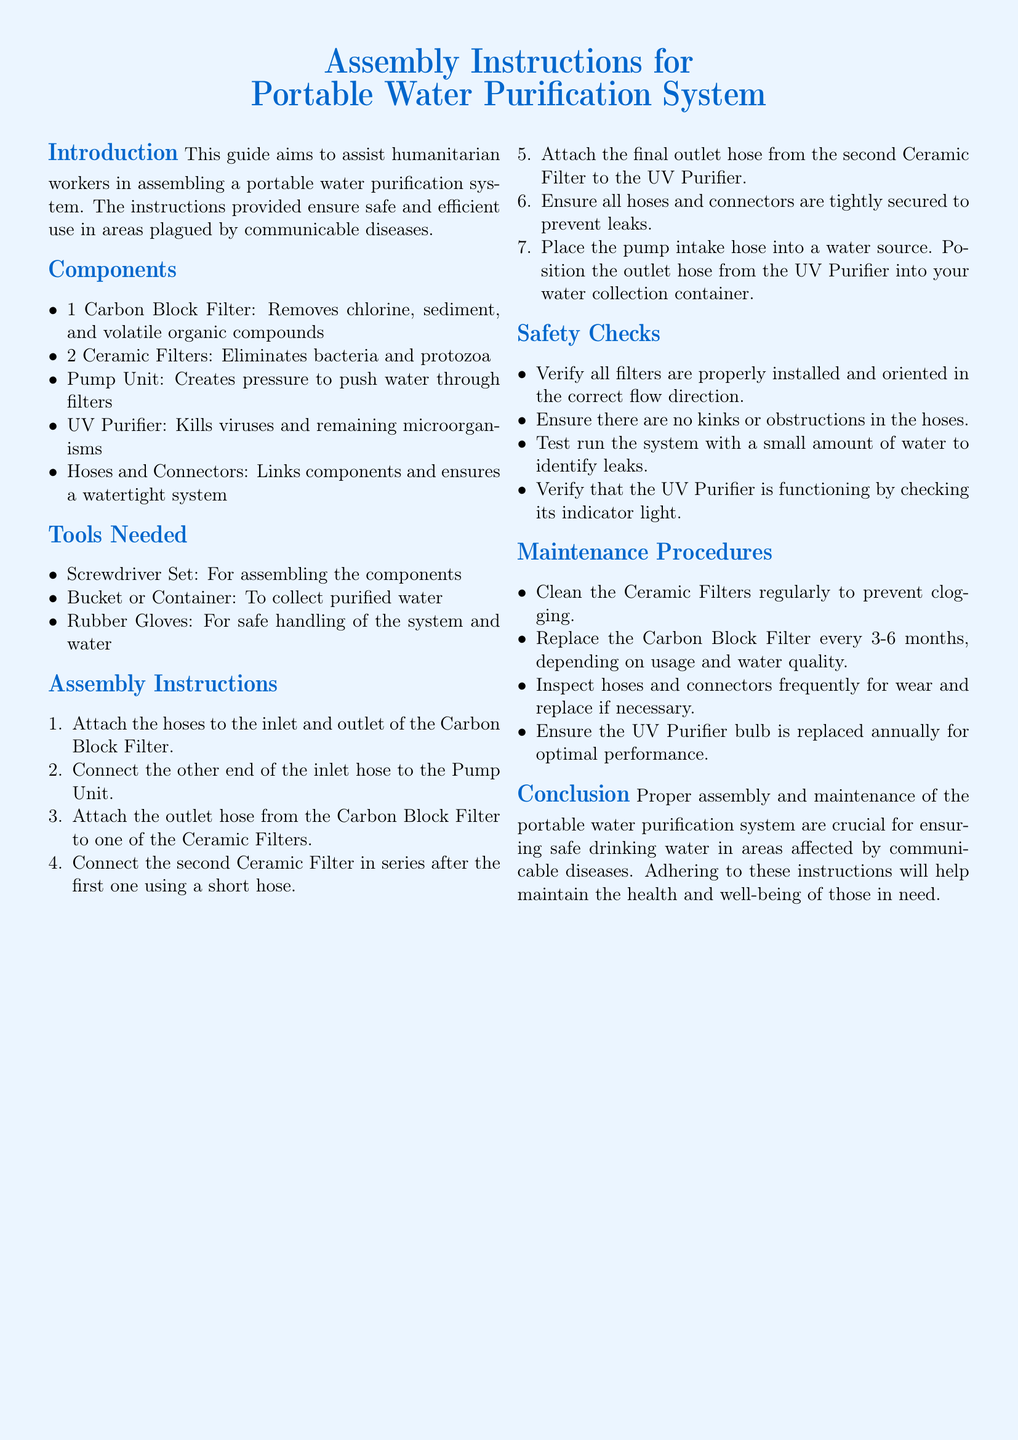What are the components of the purification system? The components listed include a Carbon Block Filter, Ceramic Filters, Pump Unit, UV Purifier, and Hoses and Connectors.
Answer: Carbon Block Filter, Ceramic Filters, Pump Unit, UV Purifier, Hoses and Connectors How many Ceramic Filters are included? The instructions specify two Ceramic Filters are included as components.
Answer: 2 What tool is required for handling the system safely? The document mentions the need for Rubber Gloves for safe handling.
Answer: Rubber Gloves What is the first step in the assembly instructions? The first step outlined is to attach the hoses to the inlet and outlet of the Carbon Block Filter.
Answer: Attach the hoses to the inlet and outlet of the Carbon Block Filter What should be tested to verify the UV Purifier is functioning? The document states that one should check its indicator light to verify functioning.
Answer: Indicator light What is the recommended replacement interval for the Carbon Block Filter? Users are advised to replace the Carbon Block Filter every 3-6 months, based on usage.
Answer: Every 3-6 months What is the main purpose of this document? The main aim is to assist humanitarian workers in assembling a portable water purification system.
Answer: To assist humanitarian workers in assembling a portable water purification system What type of document is this? This document type is categorized as assembly instructions for a specific system related to water purification.
Answer: Assembly instructions 